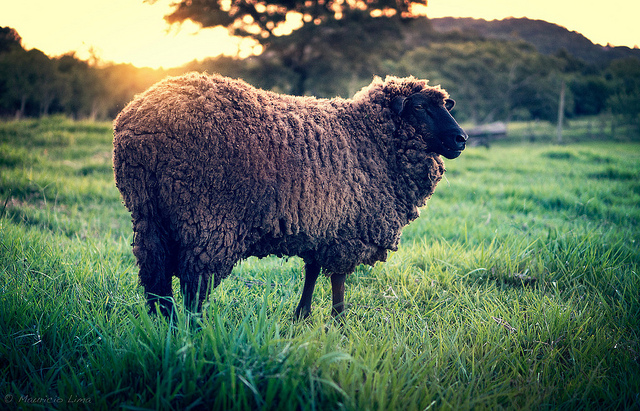Can you describe the main object in the image? Certainly! The main object in the image is a sheep. It has a thick, curly, dark brown coat that appears quite dense. The sheep is standing in a lush, green, grassy field with the warm glow of the sun casting a serene and beautiful light over the entire scene. 